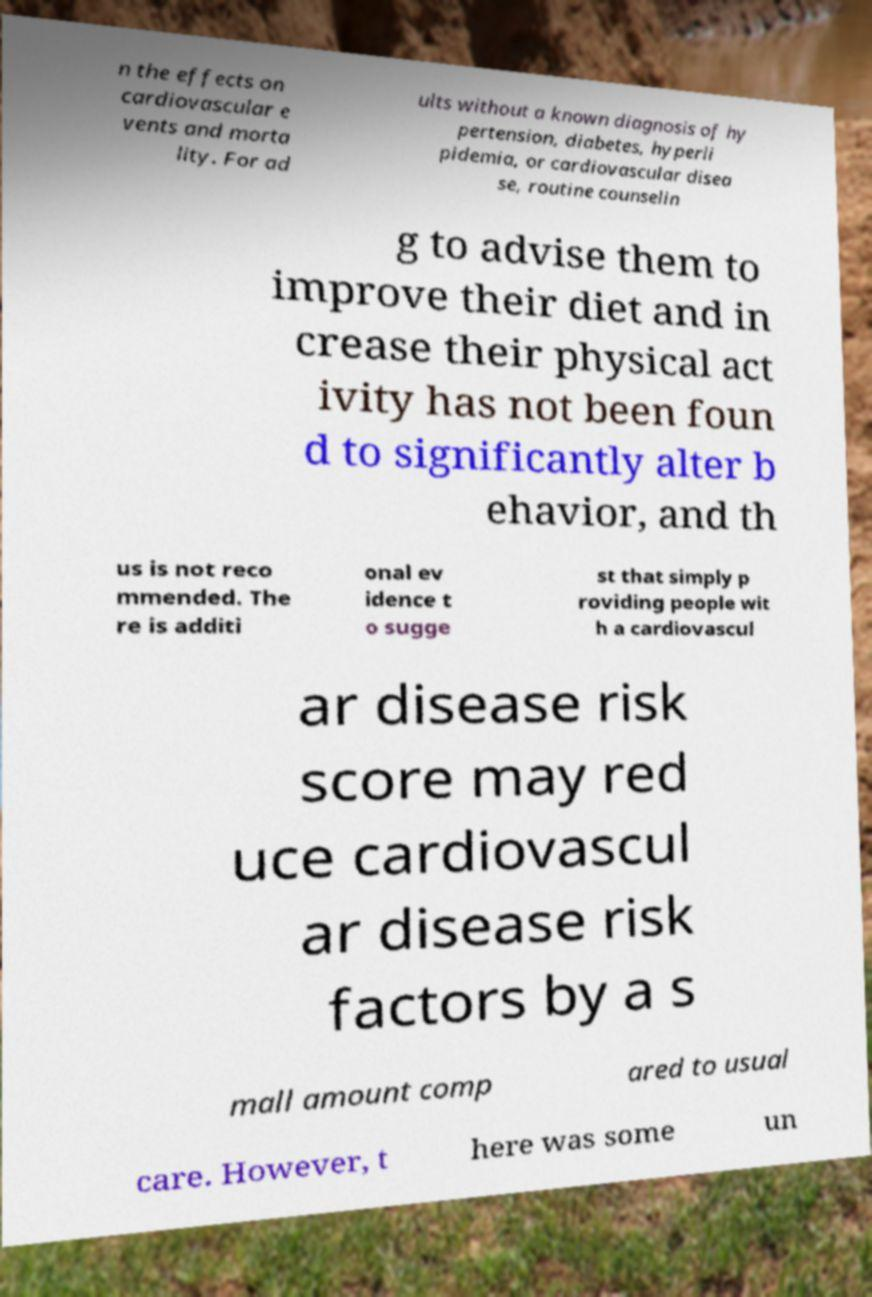I need the written content from this picture converted into text. Can you do that? n the effects on cardiovascular e vents and morta lity. For ad ults without a known diagnosis of hy pertension, diabetes, hyperli pidemia, or cardiovascular disea se, routine counselin g to advise them to improve their diet and in crease their physical act ivity has not been foun d to significantly alter b ehavior, and th us is not reco mmended. The re is additi onal ev idence t o sugge st that simply p roviding people wit h a cardiovascul ar disease risk score may red uce cardiovascul ar disease risk factors by a s mall amount comp ared to usual care. However, t here was some un 